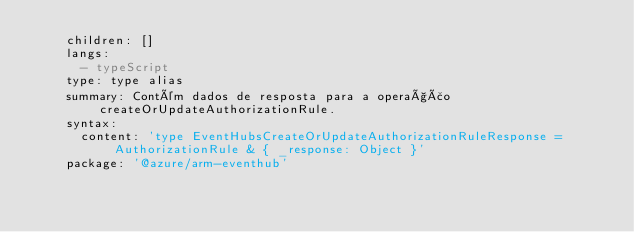<code> <loc_0><loc_0><loc_500><loc_500><_YAML_>    children: []
    langs:
      - typeScript
    type: type alias
    summary: Contém dados de resposta para a operação createOrUpdateAuthorizationRule.
    syntax:
      content: 'type EventHubsCreateOrUpdateAuthorizationRuleResponse = AuthorizationRule & { _response: Object }'
    package: '@azure/arm-eventhub'</code> 